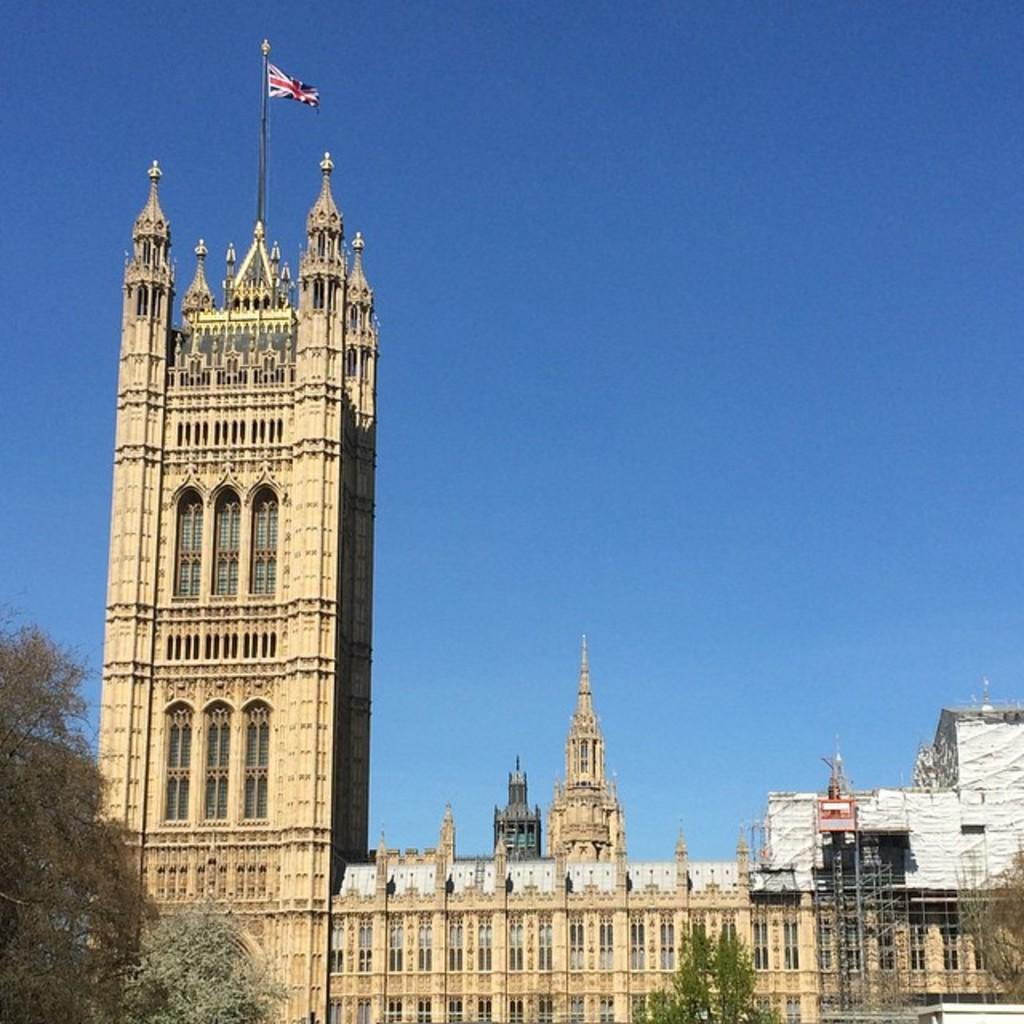What type of structures can be seen in the image? There are buildings in the image. What are some features of these buildings? The buildings have rods, walls, windows, and a pole with a flag on top of one of them. What can be seen in the background of the image? The sky is visible in the background of the image. Are there any natural elements present in the image? Yes, there are trees in the image. What is the profit margin of the company that owns the buildings in the image? There is no information about the company that owns the buildings or their profit margin in the image. How does the wind affect the trees in the image? The image does not show any movement of the trees, so it is impossible to determine the effect of the wind on them. 